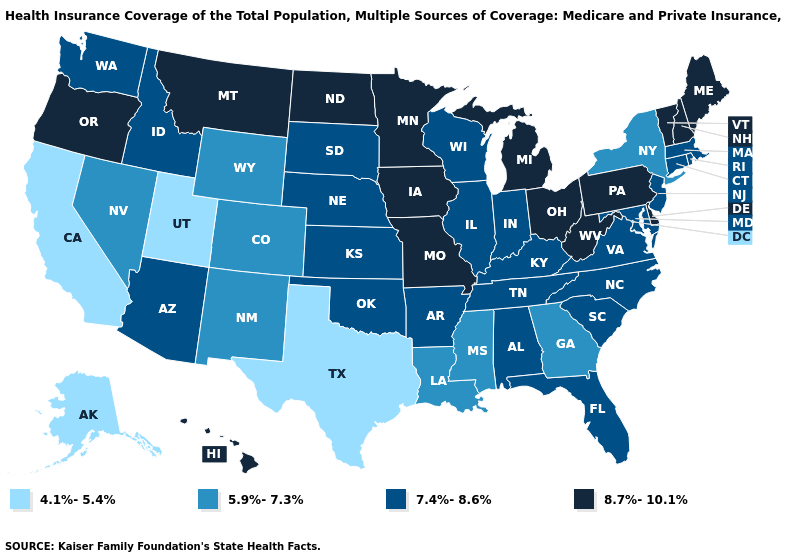Does the first symbol in the legend represent the smallest category?
Short answer required. Yes. Among the states that border Michigan , does Ohio have the highest value?
Be succinct. Yes. What is the value of Idaho?
Answer briefly. 7.4%-8.6%. Does Idaho have the same value as New York?
Be succinct. No. What is the lowest value in states that border Kentucky?
Write a very short answer. 7.4%-8.6%. Which states hav the highest value in the Northeast?
Quick response, please. Maine, New Hampshire, Pennsylvania, Vermont. Among the states that border Nebraska , which have the highest value?
Concise answer only. Iowa, Missouri. Name the states that have a value in the range 8.7%-10.1%?
Give a very brief answer. Delaware, Hawaii, Iowa, Maine, Michigan, Minnesota, Missouri, Montana, New Hampshire, North Dakota, Ohio, Oregon, Pennsylvania, Vermont, West Virginia. Does the first symbol in the legend represent the smallest category?
Concise answer only. Yes. Name the states that have a value in the range 4.1%-5.4%?
Concise answer only. Alaska, California, Texas, Utah. Name the states that have a value in the range 4.1%-5.4%?
Concise answer only. Alaska, California, Texas, Utah. Which states have the lowest value in the Northeast?
Concise answer only. New York. Name the states that have a value in the range 5.9%-7.3%?
Quick response, please. Colorado, Georgia, Louisiana, Mississippi, Nevada, New Mexico, New York, Wyoming. Does Nebraska have a higher value than New Mexico?
Write a very short answer. Yes. Is the legend a continuous bar?
Keep it brief. No. 